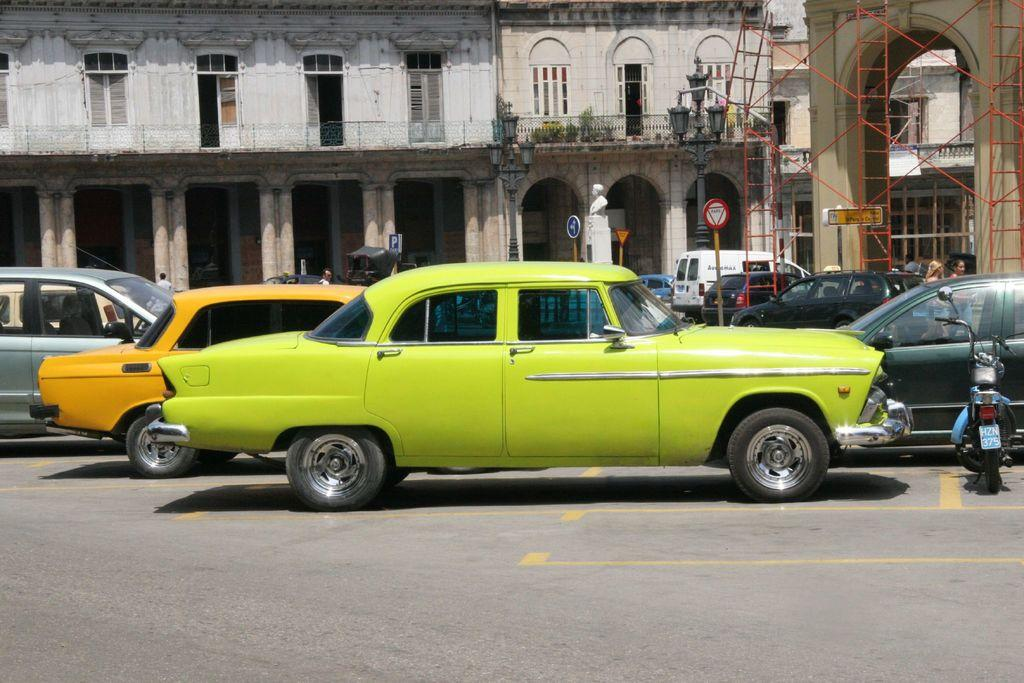Provide a one-sentence caption for the provided image. A red outlined traffic sign reads Pare in the middle of the street.. 